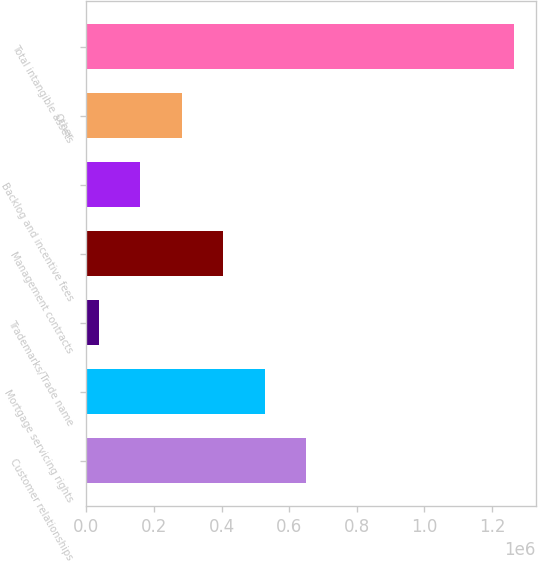Convert chart to OTSL. <chart><loc_0><loc_0><loc_500><loc_500><bar_chart><fcel>Customer relationships<fcel>Mortgage servicing rights<fcel>Trademarks/Trade name<fcel>Management contracts<fcel>Backlog and incentive fees<fcel>Other<fcel>Total intangible assets<nl><fcel>650754<fcel>527753<fcel>35748<fcel>404752<fcel>158749<fcel>281750<fcel>1.26576e+06<nl></chart> 